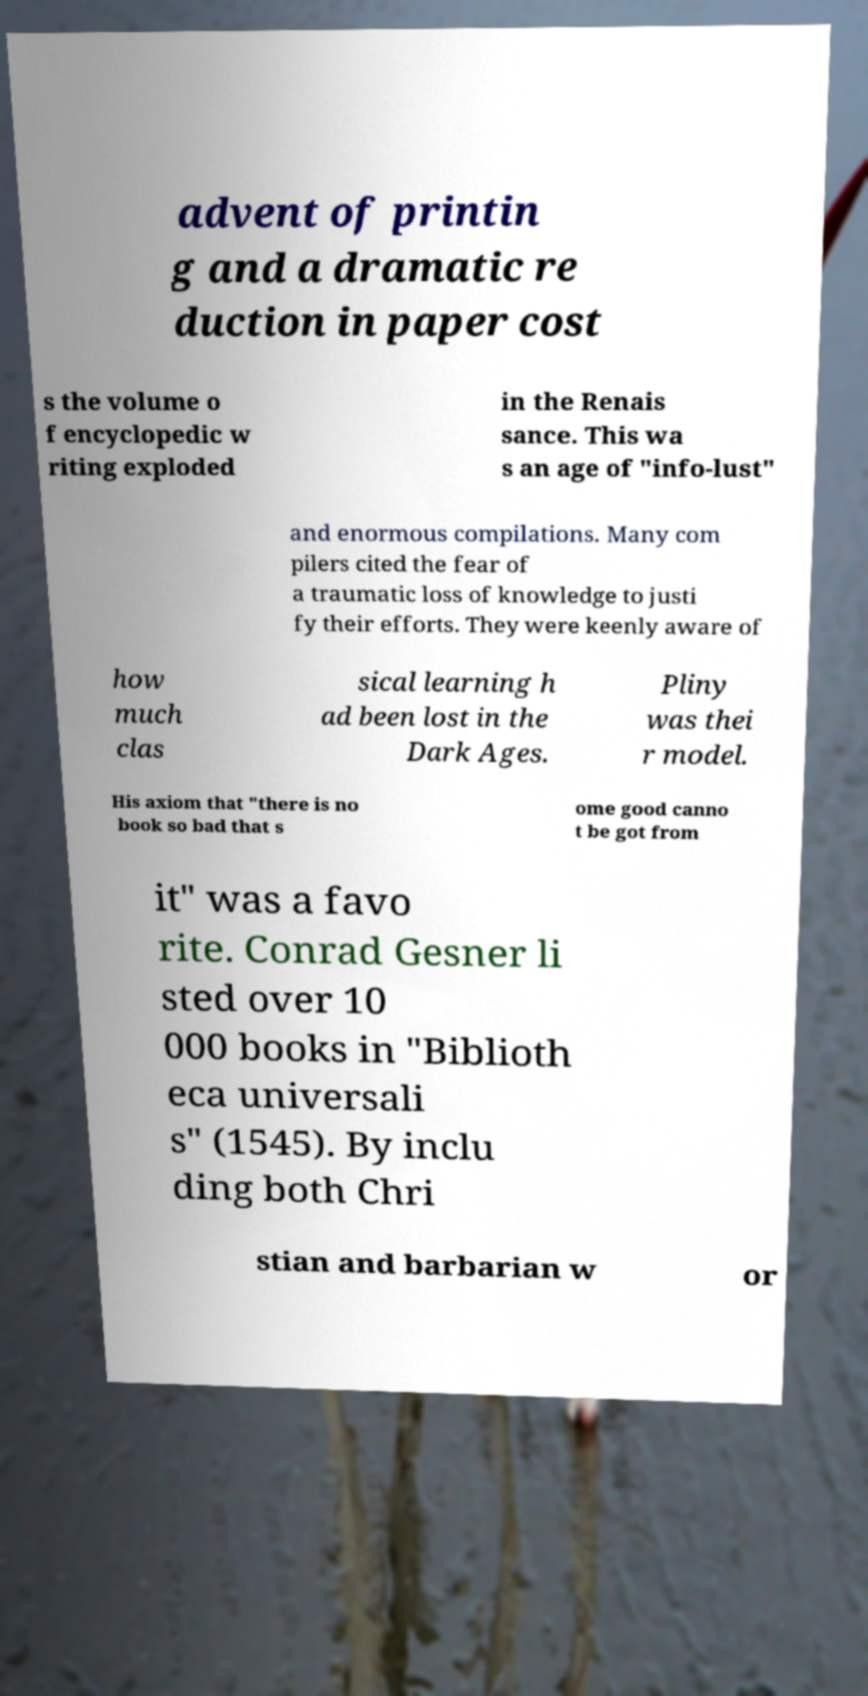Please read and relay the text visible in this image. What does it say? advent of printin g and a dramatic re duction in paper cost s the volume o f encyclopedic w riting exploded in the Renais sance. This wa s an age of "info-lust" and enormous compilations. Many com pilers cited the fear of a traumatic loss of knowledge to justi fy their efforts. They were keenly aware of how much clas sical learning h ad been lost in the Dark Ages. Pliny was thei r model. His axiom that "there is no book so bad that s ome good canno t be got from it" was a favo rite. Conrad Gesner li sted over 10 000 books in "Biblioth eca universali s" (1545). By inclu ding both Chri stian and barbarian w or 